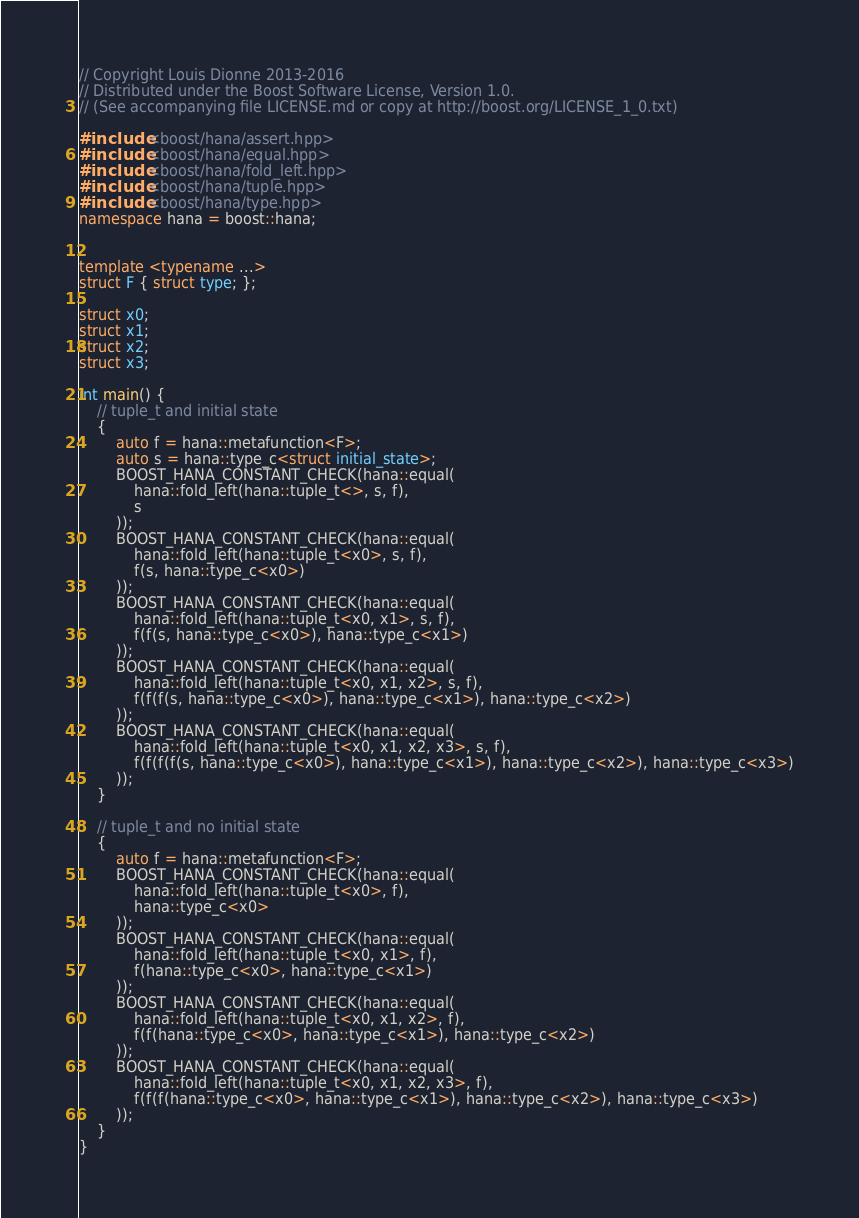Convert code to text. <code><loc_0><loc_0><loc_500><loc_500><_C++_>// Copyright Louis Dionne 2013-2016
// Distributed under the Boost Software License, Version 1.0.
// (See accompanying file LICENSE.md or copy at http://boost.org/LICENSE_1_0.txt)

#include <boost/hana/assert.hpp>
#include <boost/hana/equal.hpp>
#include <boost/hana/fold_left.hpp>
#include <boost/hana/tuple.hpp>
#include <boost/hana/type.hpp>
namespace hana = boost::hana;


template <typename ...>
struct F { struct type; };

struct x0;
struct x1;
struct x2;
struct x3;

int main() {
    // tuple_t and initial state
    {
        auto f = hana::metafunction<F>;
        auto s = hana::type_c<struct initial_state>;
        BOOST_HANA_CONSTANT_CHECK(hana::equal(
            hana::fold_left(hana::tuple_t<>, s, f),
            s
        ));
        BOOST_HANA_CONSTANT_CHECK(hana::equal(
            hana::fold_left(hana::tuple_t<x0>, s, f),
            f(s, hana::type_c<x0>)
        ));
        BOOST_HANA_CONSTANT_CHECK(hana::equal(
            hana::fold_left(hana::tuple_t<x0, x1>, s, f),
            f(f(s, hana::type_c<x0>), hana::type_c<x1>)
        ));
        BOOST_HANA_CONSTANT_CHECK(hana::equal(
            hana::fold_left(hana::tuple_t<x0, x1, x2>, s, f),
            f(f(f(s, hana::type_c<x0>), hana::type_c<x1>), hana::type_c<x2>)
        ));
        BOOST_HANA_CONSTANT_CHECK(hana::equal(
            hana::fold_left(hana::tuple_t<x0, x1, x2, x3>, s, f),
            f(f(f(f(s, hana::type_c<x0>), hana::type_c<x1>), hana::type_c<x2>), hana::type_c<x3>)
        ));
    }

    // tuple_t and no initial state
    {
        auto f = hana::metafunction<F>;
        BOOST_HANA_CONSTANT_CHECK(hana::equal(
            hana::fold_left(hana::tuple_t<x0>, f),
            hana::type_c<x0>
        ));
        BOOST_HANA_CONSTANT_CHECK(hana::equal(
            hana::fold_left(hana::tuple_t<x0, x1>, f),
            f(hana::type_c<x0>, hana::type_c<x1>)
        ));
        BOOST_HANA_CONSTANT_CHECK(hana::equal(
            hana::fold_left(hana::tuple_t<x0, x1, x2>, f),
            f(f(hana::type_c<x0>, hana::type_c<x1>), hana::type_c<x2>)
        ));
        BOOST_HANA_CONSTANT_CHECK(hana::equal(
            hana::fold_left(hana::tuple_t<x0, x1, x2, x3>, f),
            f(f(f(hana::type_c<x0>, hana::type_c<x1>), hana::type_c<x2>), hana::type_c<x3>)
        ));
    }
}
</code> 